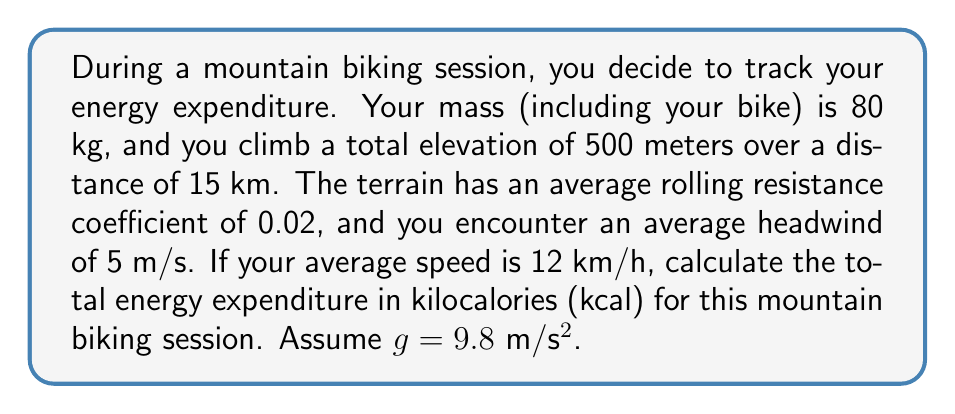Can you answer this question? To calculate the total energy expenditure, we need to consider several factors:

1. Gravitational potential energy (climbing)
2. Rolling resistance
3. Air resistance
4. Kinetic energy (negligible if start and end speeds are the same)

Let's calculate each component:

1. Gravitational potential energy:
   $E_g = mgh$
   where $m$ = 80 kg, $g$ = 9.8 m/s², $h$ = 500 m
   $E_g = 80 \times 9.8 \times 500 = 392000$ J

2. Rolling resistance:
   $E_r = \mu mgd$
   where $\mu$ = 0.02, $m$ = 80 kg, $g$ = 9.8 m/s², $d$ = 15000 m
   $E_r = 0.02 \times 80 \times 9.8 \times 15000 = 235200$ J

3. Air resistance:
   $E_a = \frac{1}{2}\rho C_d Av^2d$
   where $\rho$ = 1.225 kg/m³ (air density), $C_d$ = 1 (drag coefficient), $A$ = 0.5 m² (frontal area), $v$ = 3.33 + 5 = 8.33 m/s (bike speed + headwind), $d$ = 15000 m
   $E_a = \frac{1}{2} \times 1.225 \times 1 \times 0.5 \times 8.33^2 \times 15000 = 319614.84$ J

Total energy expenditure:
$E_{total} = E_g + E_r + E_a = 392000 + 235200 + 319614.84 = 946814.84$ J

Converting to kilocalories:
$E_{kcal} = \frac{E_{total}}{4186}$ (1 kcal = 4186 J)

$E_{kcal} = \frac{946814.84}{4186} = 226.19$ kcal
Answer: 226.19 kcal 